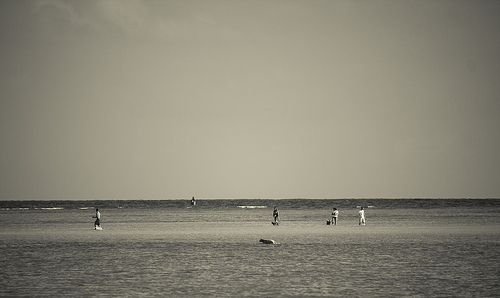Man with no shirt standing on the beach. A man without a shirt on the beach might exude a sense of freedom or relaxation, possibly seen near the water's edge with the sun highlighting his figure. 